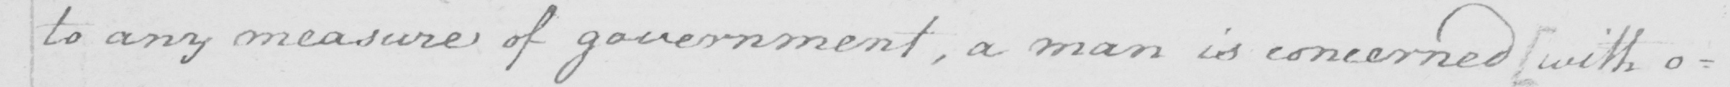What does this handwritten line say? to any measure of government  , a man is concerned  [ with o= 